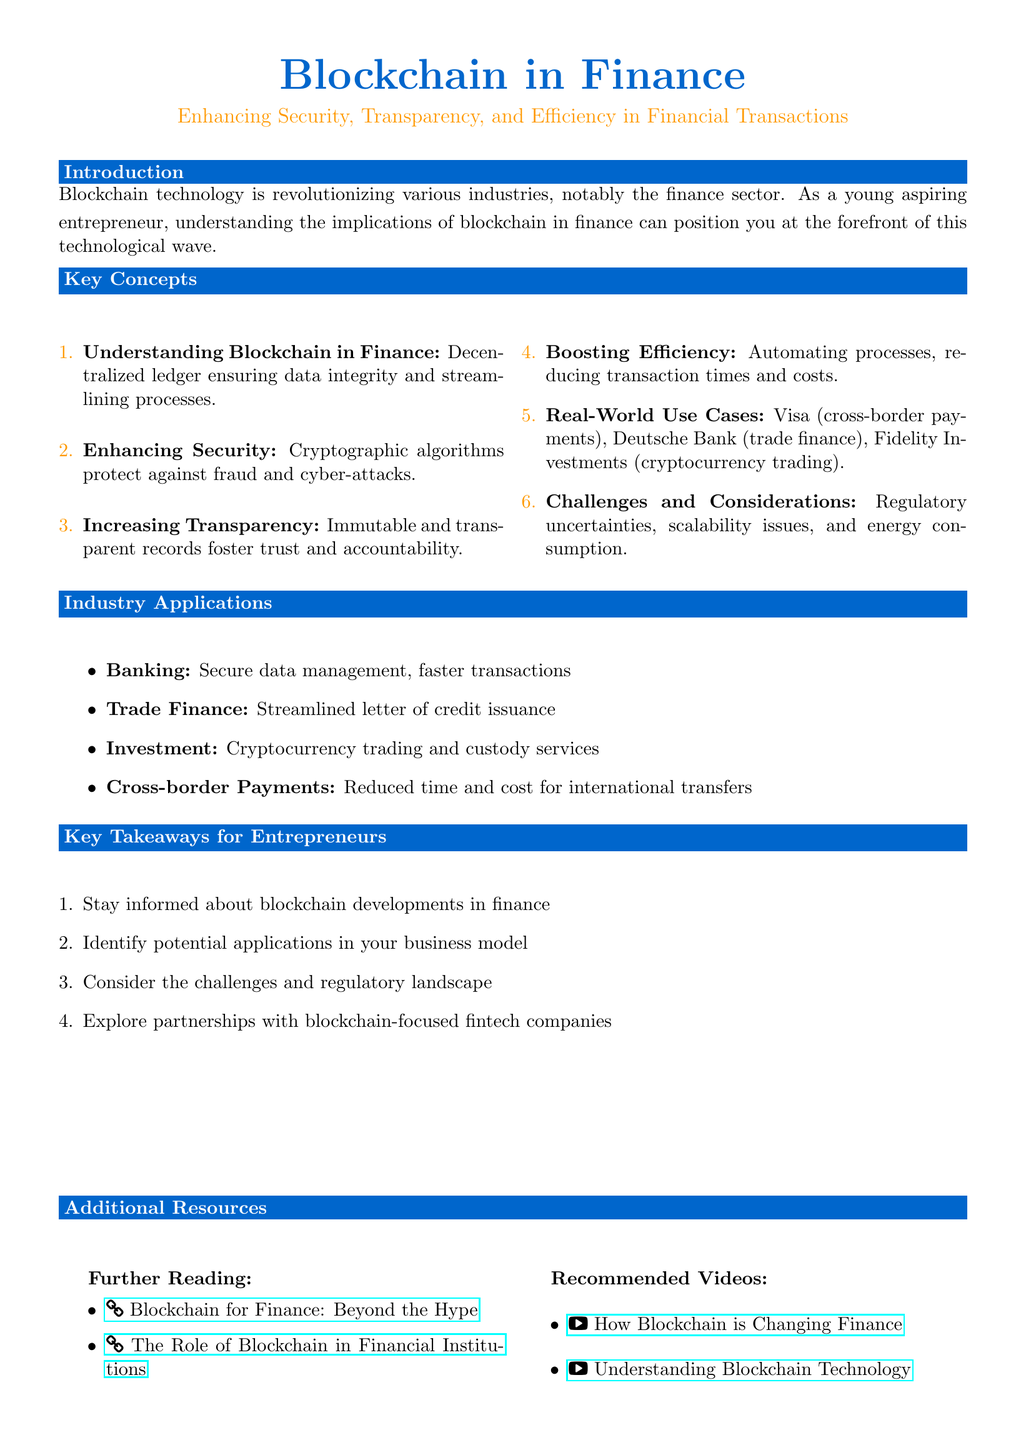What are the three benefits of blockchain in finance? The document lists three key benefits: Security, Transparency, and Efficiency.
Answer: Security, Transparency, Efficiency Which companies are mentioned as real-world use cases for blockchain in finance? The document specifies three companies that utilize blockchain: Visa, Deutsche Bank, and Fidelity Investments.
Answer: Visa, Deutsche Bank, Fidelity Investments What is one challenge associated with implementing blockchain technology in finance? The document indicates that challenges include regulatory uncertainties, scalability issues, and energy consumption, mentioning regulatory uncertainties as one.
Answer: Regulatory uncertainties What does decentralization in financial transactions ensure? The document explains that blockchain provides a decentralized ledger which ensures data integrity.
Answer: Data integrity In which industry is blockchain applied for streamlined letter of credit issuance? According to the document, blockchain is applied in Trade Finance for streamlined letter of credit issuance.
Answer: Trade Finance What is a recommended action for entrepreneurs interested in blockchain? The document suggests that entrepreneurs should stay informed about blockchain developments in finance.
Answer: Stay informed Which feature of blockchain helps improve trust in financial records? The document states that immutable and transparent records foster trust and accountability in finance.
Answer: Immutable What time reduction benefit does blockchain provide in cross-border payments? The document mentions that blockchain reduces time and cost for international transfers in cross-border payments.
Answer: Reduced time and cost What type of videos does the document recommend for further learning? The document lists recommended videos that provide understanding and information about blockchain technology in finance.
Answer: Recommended videos 